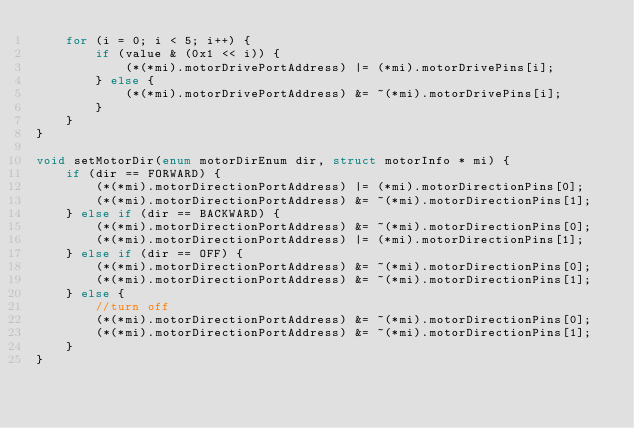Convert code to text. <code><loc_0><loc_0><loc_500><loc_500><_C_>	for (i = 0; i < 5; i++) {
		if (value & (0x1 << i)) {
			(*(*mi).motorDrivePortAddress) |= (*mi).motorDrivePins[i];
		} else {
			(*(*mi).motorDrivePortAddress) &= ~(*mi).motorDrivePins[i];
		}
	}
}

void setMotorDir(enum motorDirEnum dir, struct motorInfo * mi) {
	if (dir == FORWARD) {
		(*(*mi).motorDirectionPortAddress) |= (*mi).motorDirectionPins[0];
		(*(*mi).motorDirectionPortAddress) &= ~(*mi).motorDirectionPins[1];
	} else if (dir == BACKWARD) {
		(*(*mi).motorDirectionPortAddress) &= ~(*mi).motorDirectionPins[0];
		(*(*mi).motorDirectionPortAddress) |= (*mi).motorDirectionPins[1];
	} else if (dir == OFF) {
		(*(*mi).motorDirectionPortAddress) &= ~(*mi).motorDirectionPins[0];
		(*(*mi).motorDirectionPortAddress) &= ~(*mi).motorDirectionPins[1];
	} else {
		//turn off
		(*(*mi).motorDirectionPortAddress) &= ~(*mi).motorDirectionPins[0];
		(*(*mi).motorDirectionPortAddress) &= ~(*mi).motorDirectionPins[1];
	}
}
</code> 